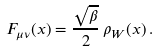Convert formula to latex. <formula><loc_0><loc_0><loc_500><loc_500>F _ { \mu \nu } ( x ) = \frac { \sqrt { \beta } } { 2 } \, \rho _ { W } ( x ) \, .</formula> 